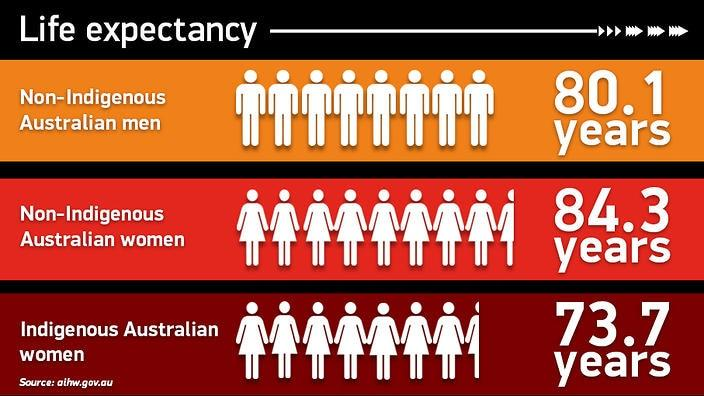Point out several critical features in this image. According to data, the difference in the life expectancy of non-indigenous women and men in Australia is 4.2 years. The difference in life expectancy between non-indigenous Australian women and Indigenous Australian women is 10.6 years, according to the most recent data. 